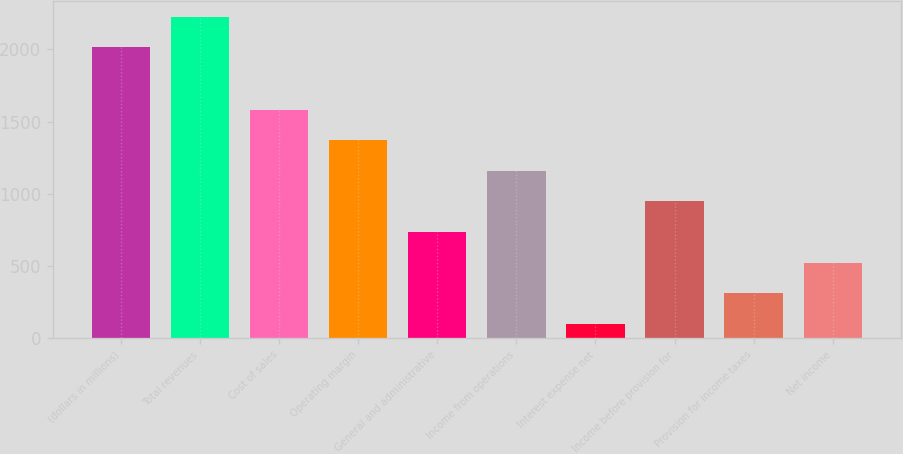<chart> <loc_0><loc_0><loc_500><loc_500><bar_chart><fcel>(dollars in millions)<fcel>Total revenues<fcel>Cost of sales<fcel>Operating margin<fcel>General and administrative<fcel>Income from operations<fcel>Interest expense net<fcel>Income before provision for<fcel>Provision for income taxes<fcel>Net income<nl><fcel>2015<fcel>2226.73<fcel>1581.31<fcel>1369.58<fcel>734.39<fcel>1157.85<fcel>99.2<fcel>946.12<fcel>310.93<fcel>522.66<nl></chart> 